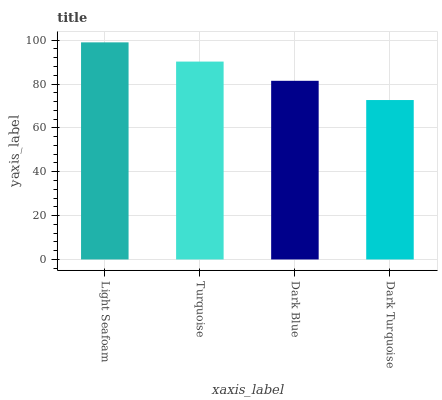Is Dark Turquoise the minimum?
Answer yes or no. Yes. Is Light Seafoam the maximum?
Answer yes or no. Yes. Is Turquoise the minimum?
Answer yes or no. No. Is Turquoise the maximum?
Answer yes or no. No. Is Light Seafoam greater than Turquoise?
Answer yes or no. Yes. Is Turquoise less than Light Seafoam?
Answer yes or no. Yes. Is Turquoise greater than Light Seafoam?
Answer yes or no. No. Is Light Seafoam less than Turquoise?
Answer yes or no. No. Is Turquoise the high median?
Answer yes or no. Yes. Is Dark Blue the low median?
Answer yes or no. Yes. Is Light Seafoam the high median?
Answer yes or no. No. Is Light Seafoam the low median?
Answer yes or no. No. 